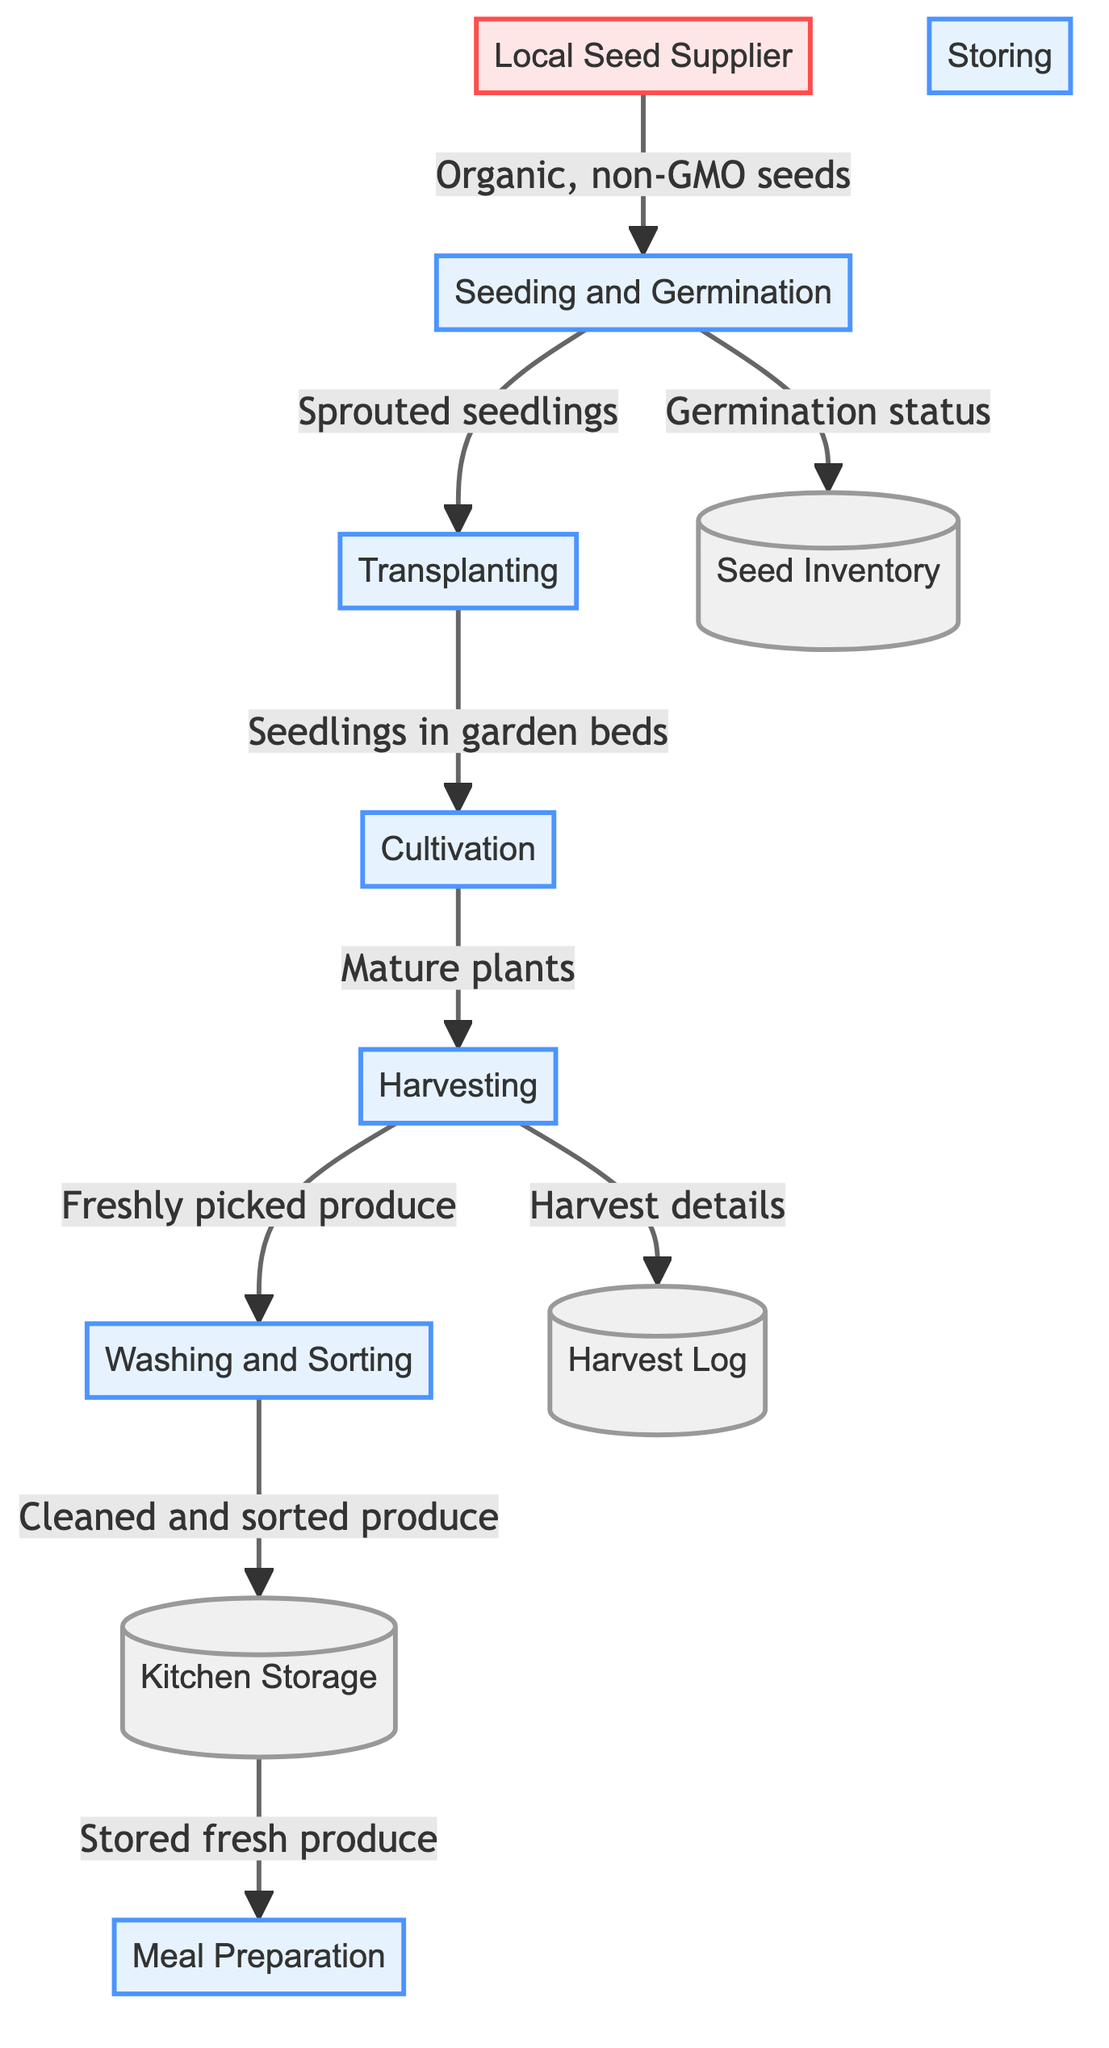What is the starting point in the diagram? The starting point in the diagram is the "Local Seed Supplier," which provides organic, non-GMO seeds. This is indicated by the arrow directed from this entity to the first process.
Answer: Local Seed Supplier How many processes are in the diagram? The diagram lists a total of seven processes that form the workflow from seeding to meal preparation. These processes include Seeding and Germination, Transplanting, Cultivation, Harvesting, Washing and Sorting, Storing, and Meal Preparation.
Answer: 7 What information flows from Harvesting to Washing and Sorting? The information flowing from Harvesting to Washing and Sorting is "Freshly picked produce." This is represented by the directed arrow between these two processes in the diagram.
Answer: Freshly picked produce Which datastore receives information from Seeding and Germination? The datastores receiving information from Seeding and Germination are "Seed Inventory" and "Transplanting." The "Seed Inventory" receives "Germination status," and "Transplanting" receives "Sprouted seedlings."
Answer: Seed Inventory, Transplanting What is the final step in the workflow represented in the diagram? The final step in the workflow is "Meal Preparation," which utilizes stored fresh produce from the "Kitchen Storage" datastore. This is shown by the arrow originating from Kitchen Storage leading to Meal Preparation.
Answer: Meal Preparation What type of seeds does the Local Seed Supplier provide? The Local Seed Supplier provides "Organic, non-GMO seeds," which is specified in the data flow illustrating its connection to the Seeding and Germination process.
Answer: Organic, non-GMO seeds What is logged in the Harvest Log? The Harvest Log records "Harvest details," which is the information sent from the Harvesting process. This is illustrated by the arrow from Harvesting to Harvest Log.
Answer: Harvest details 